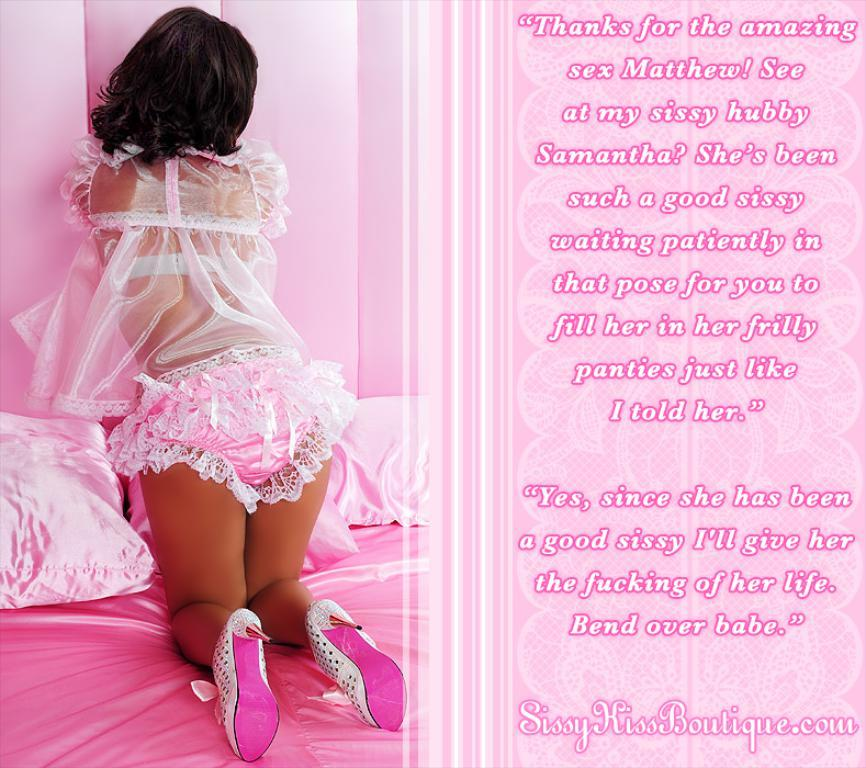Who is present in the image? There is a girl in the image. What is the girl doing in the image? The girl is standing on the bed. Is there any text visible in the image? Yes, there is some text in the image. What type of insurance policy is the girl holding in the image? There is no insurance policy present in the image; it only features a girl standing on the bed and some text. What kind of brush is the girl using to paint the wall in the image? There is no brush or painting activity depicted in the image; the girl is simply standing on the bed. 